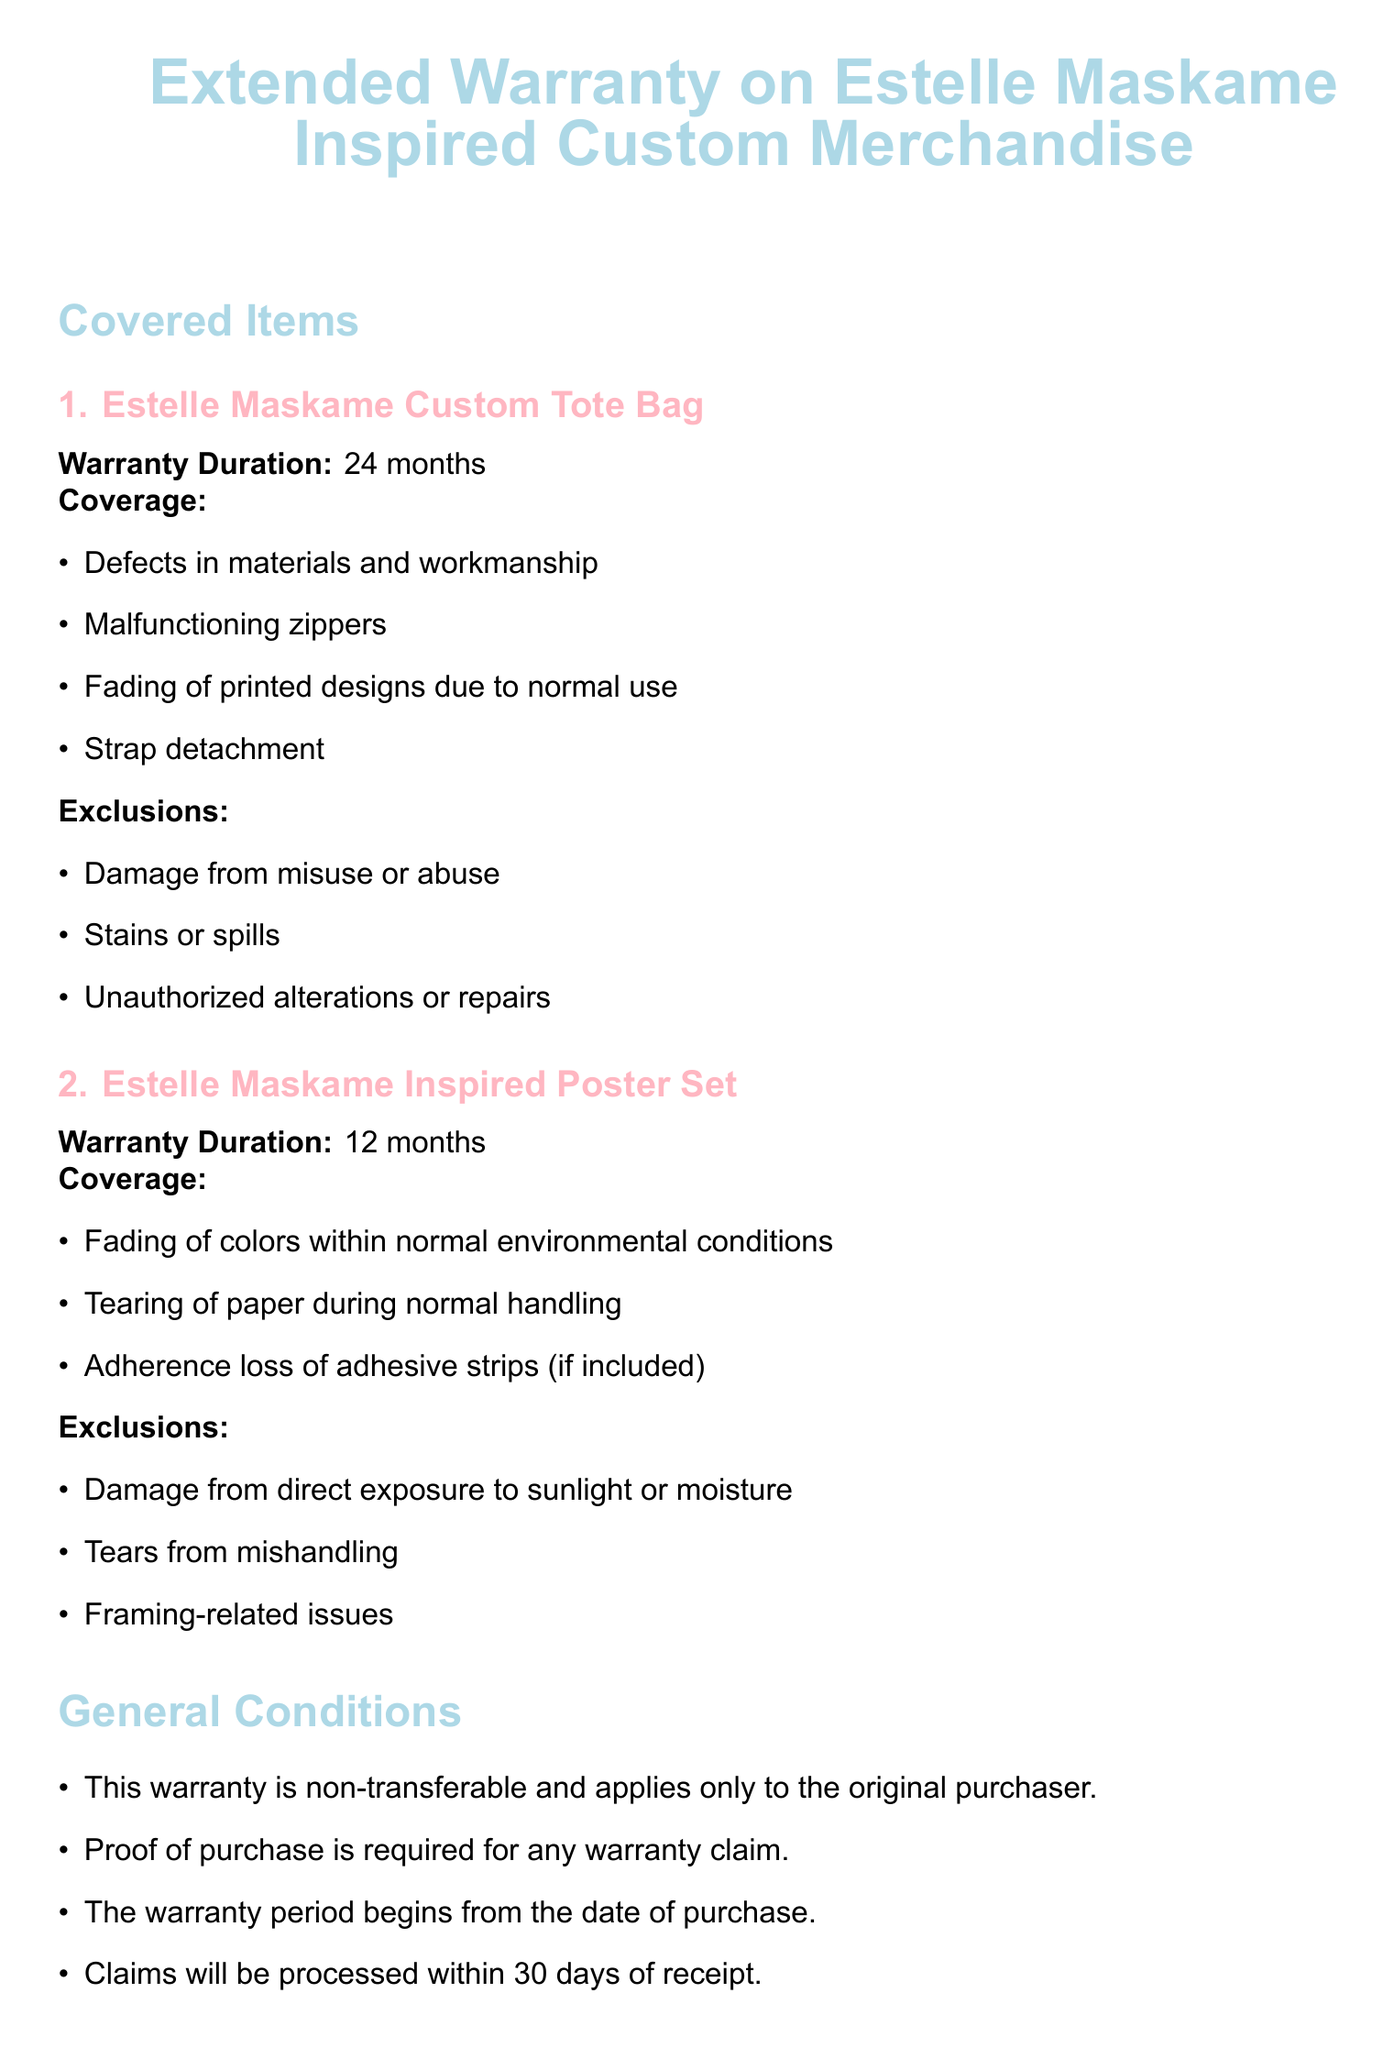What is the warranty duration for the Estelle Maskame Custom Tote Bag? The warranty duration for the tote bag is explicitly mentioned in the document as 24 months.
Answer: 24 months What types of damage are excluded from the warranty on the Estelle Maskame Inspired Poster Set? The document lists specific exclusions under which the warranty will not cover the poster set, including damage from sunlight and mishandling.
Answer: Damage from direct exposure to sunlight or moisture, tears from mishandling What must be provided for any warranty claim? The document specifies that proof of purchase is required for warranty claims, indicating the essential information needed to process claims.
Answer: Proof of purchase If an item is not available for replacement, what will be provided? The warranty policy outlines that if the original item is unavailable, a similar product of equal or greater value will be offered as a replacement.
Answer: A similar product of equal or greater value How long is the warranty for the Estelle Maskame Inspired Poster Set? The warranty duration for the poster set is outlined in the coverage section, making it easy to find this specific time frame.
Answer: 12 months What is the maximum time frame for claims processing? The document clearly states that claims will be processed within 30 days of receipt, indicating a specific limit for this procedure.
Answer: 30 days What should you do first to initiate a warranty claim? The document instructs that the first step for initiating a claim is to contact customer service, which is the beginning of the claims procedure.
Answer: Contact customer service at support@estellefansmerch.com What happens to repaired or replaced items in terms of warranty coverage? The warranty states that repaired or replaced items are covered for the remainder of the original warranty period or for 90 days from the date of repair or replacement, whichever lasts longer.
Answer: The remainder of the original warranty period or 90 days from the date of repair or replacement, whichever is longer 